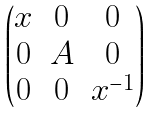<formula> <loc_0><loc_0><loc_500><loc_500>\begin{pmatrix} x & 0 & 0 \\ 0 & A & 0 \\ 0 & 0 & x ^ { - 1 } \end{pmatrix}</formula> 